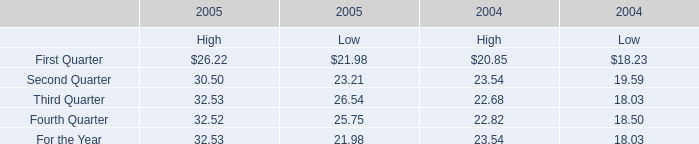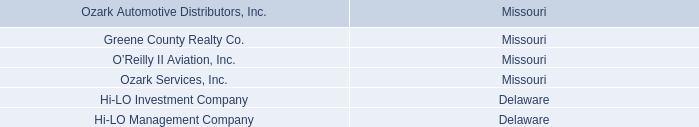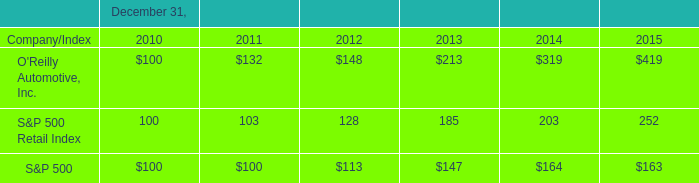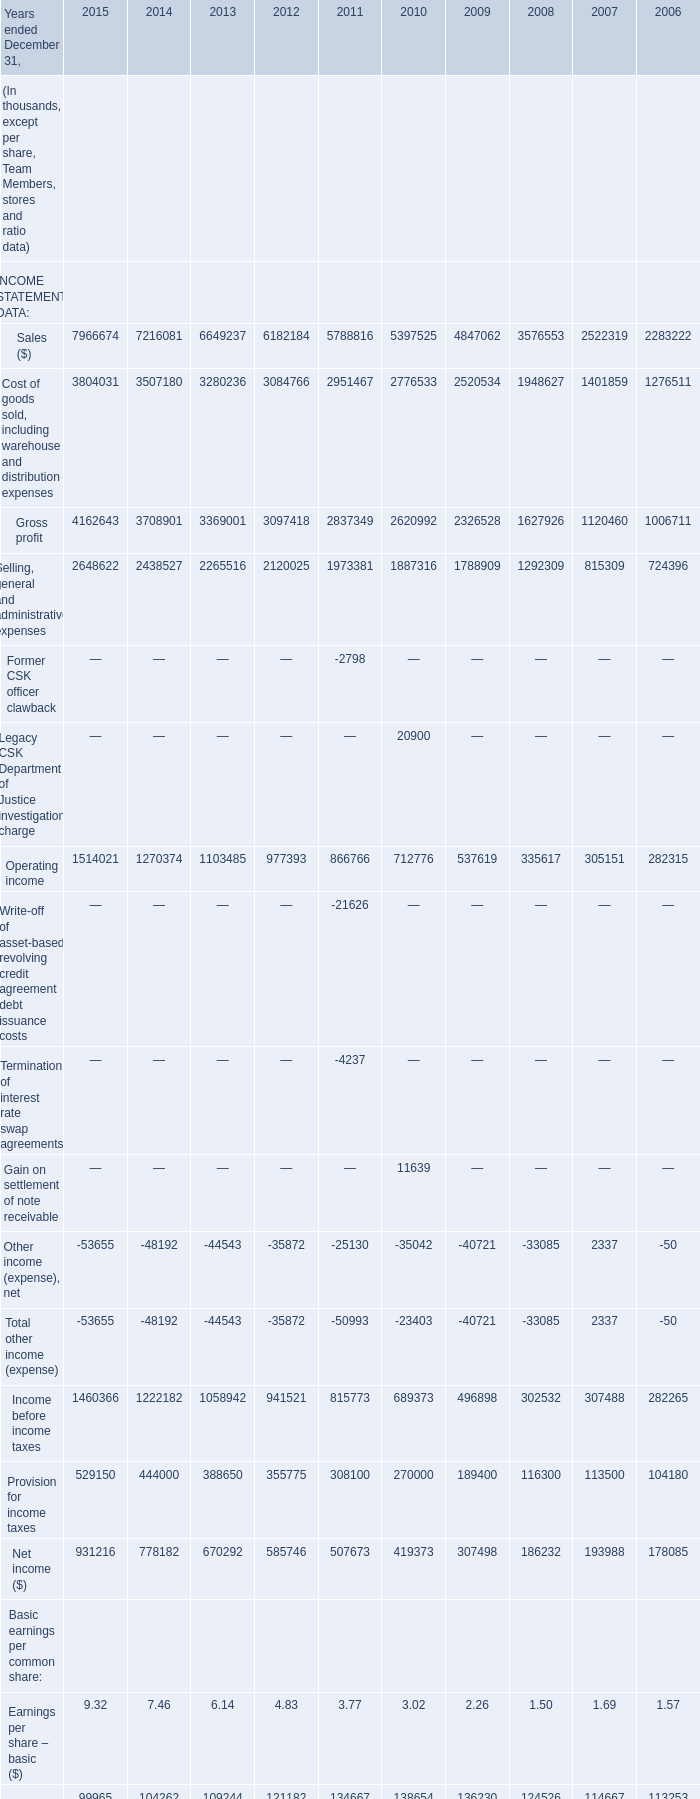What was the average value of Income before income taxes, Provision for income taxes, Net income ($) in 2012? (in thousand) 
Computations: (((941521 + 355775) + 585746) / 3)
Answer: 627680.66667. 